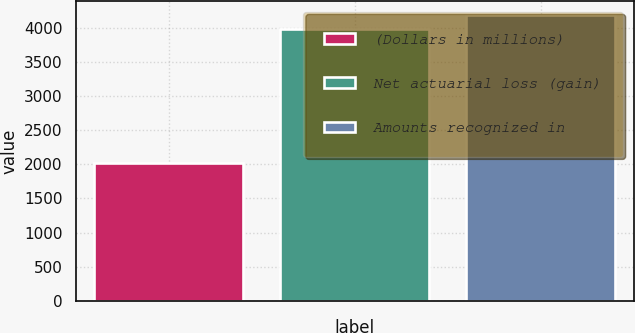Convert chart to OTSL. <chart><loc_0><loc_0><loc_500><loc_500><bar_chart><fcel>(Dollars in millions)<fcel>Net actuarial loss (gain)<fcel>Amounts recognized in<nl><fcel>2017<fcel>3992<fcel>4189.5<nl></chart> 